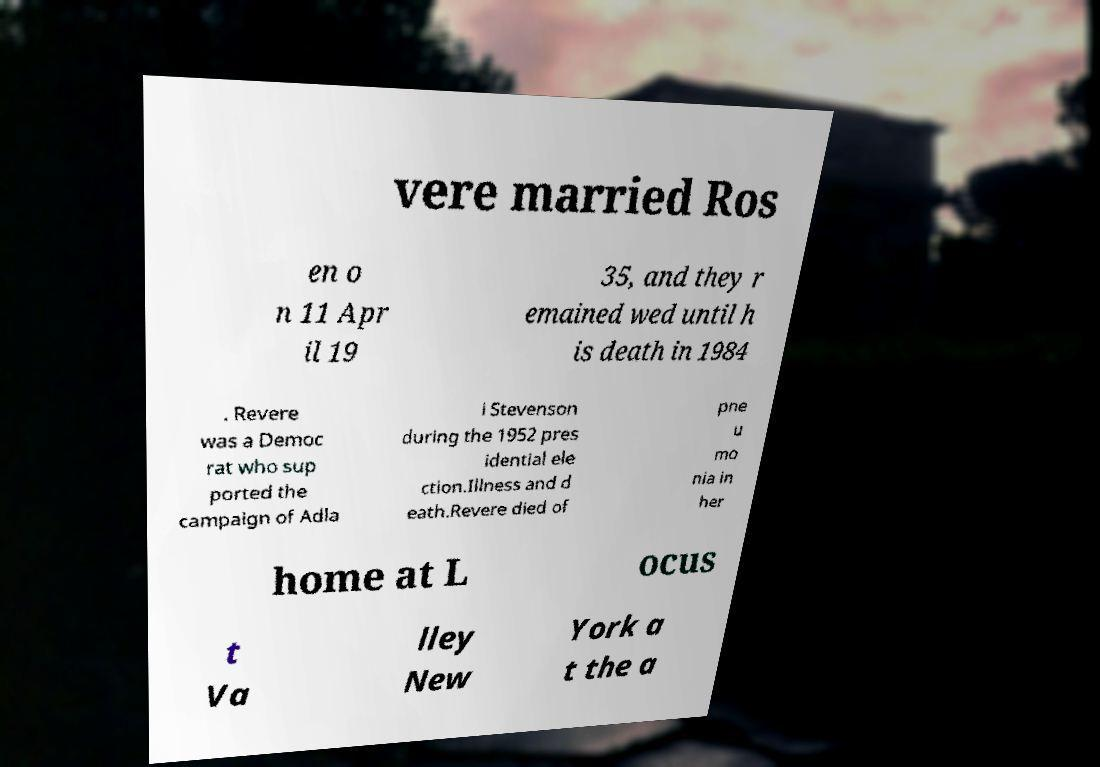I need the written content from this picture converted into text. Can you do that? vere married Ros en o n 11 Apr il 19 35, and they r emained wed until h is death in 1984 . Revere was a Democ rat who sup ported the campaign of Adla i Stevenson during the 1952 pres idential ele ction.Illness and d eath.Revere died of pne u mo nia in her home at L ocus t Va lley New York a t the a 